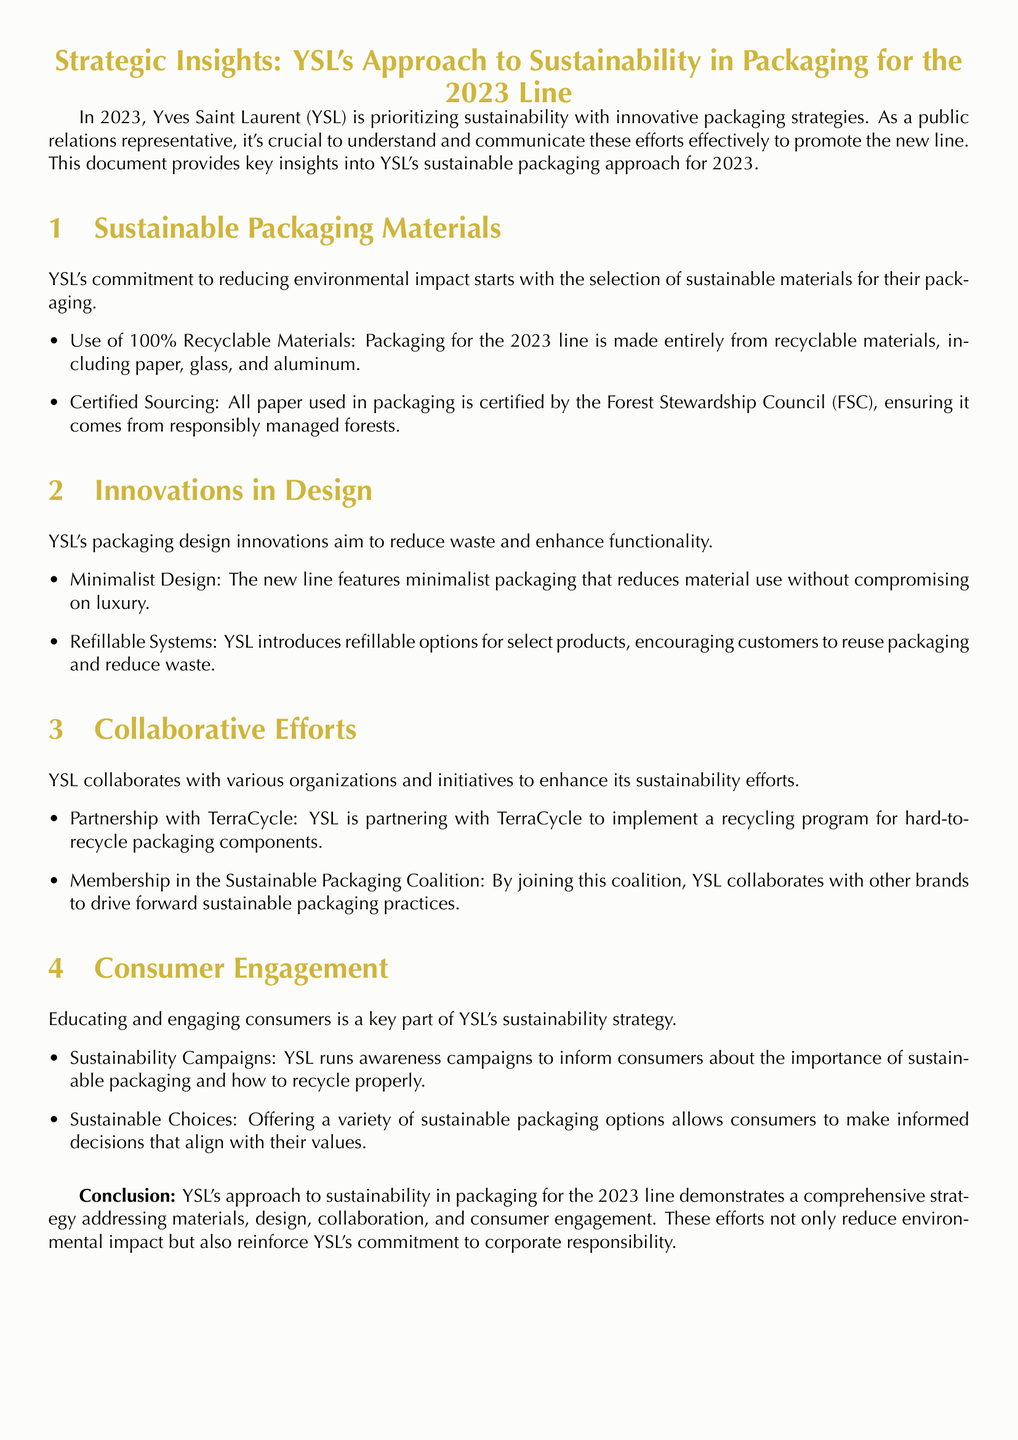What is the main focus of YSL in 2023? The main focus of YSL in 2023 is on sustainability with innovative packaging strategies.
Answer: sustainability What materials are used for the packaging of the 2023 line? The packaging for the 2023 line is made entirely from recyclable materials, including paper, glass, and aluminum.
Answer: recyclable materials Which certification is mentioned for YSL's paper packaging? The paper used in packaging is certified by the Forest Stewardship Council (FSC).
Answer: Forest Stewardship Council What design approach is taken to reduce waste? YSL features a minimalist design that reduces material use.
Answer: minimalist design With which organization is YSL partnering for recycling initiatives? YSL is partnering with TerraCycle to implement a recycling program.
Answer: TerraCycle What is one of the consumer engagement strategies mentioned? YSL runs awareness campaigns to inform consumers about sustainable packaging.
Answer: awareness campaigns How does YSL encourage product reuse? YSL introduces refillable options for select products.
Answer: refillable options What coalition does YSL belong to for sustainable practices? YSL is a member of the Sustainable Packaging Coalition.
Answer: Sustainable Packaging Coalition What is the ultimate goal of YSL's sustainability efforts? The goal is to reduce environmental impact and reinforce corporate responsibility.
Answer: reduce environmental impact 